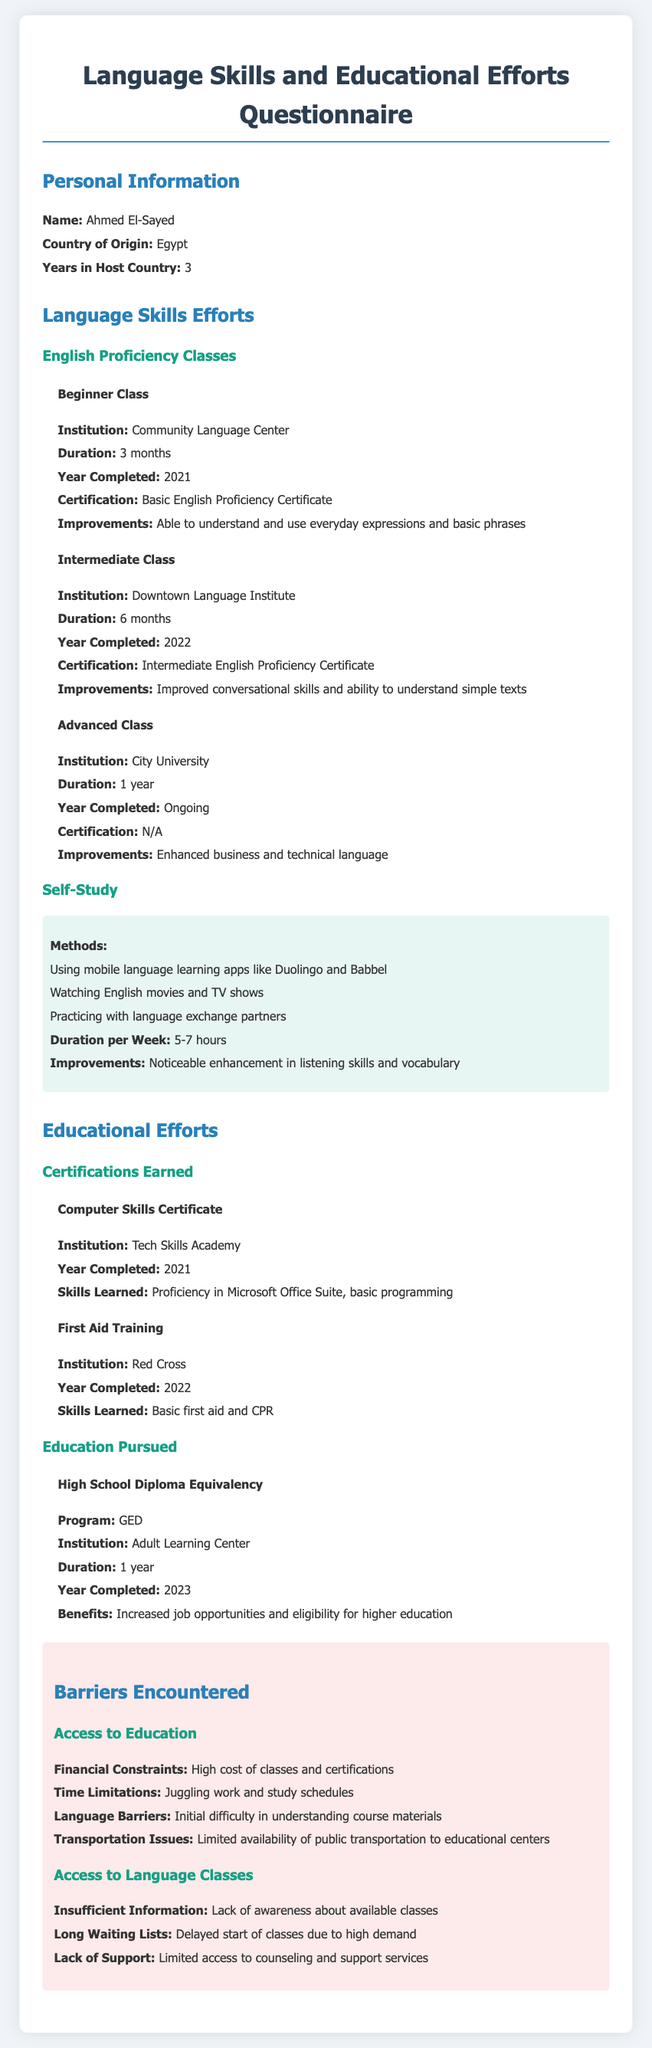What is Ahmed El-Sayed's country of origin? The document states that Ahmed El-Sayed's country of origin is Egypt.
Answer: Egypt How many years has Ahmed been in the host country? The document indicates that Ahmed has been in the host country for 3 years.
Answer: 3 What is the name of the certification earned after the Intermediate Class? The document mentions the certification earned is the Intermediate English Proficiency Certificate.
Answer: Intermediate English Proficiency Certificate How long did Ahmed study for the High School Diploma Equivalency? The document states that the duration for the High School Diploma Equivalency program was 1 year.
Answer: 1 year What are the financial constraints mentioned as a barrier? The document lists high cost of classes and certifications as a financial constraint.
Answer: High cost of classes and certifications Which institution provided the Computer Skills Certificate? According to the document, the Computer Skills Certificate was provided by Tech Skills Academy.
Answer: Tech Skills Academy What is one improvement noted from self-study efforts? The document states that there was a noticeable enhancement in listening skills and vocabulary.
Answer: Noticeable enhancement in listening skills and vocabulary What barriers are reported regarding access to language classes? The document mentions insufficient information, long waiting lists, and lack of support as barriers.
Answer: Insufficient information, long waiting lists, lack of support What is the duration of the Advanced Class that Ahmed is currently attending? The document indicates that the duration of the Advanced Class is 1 year.
Answer: 1 year 